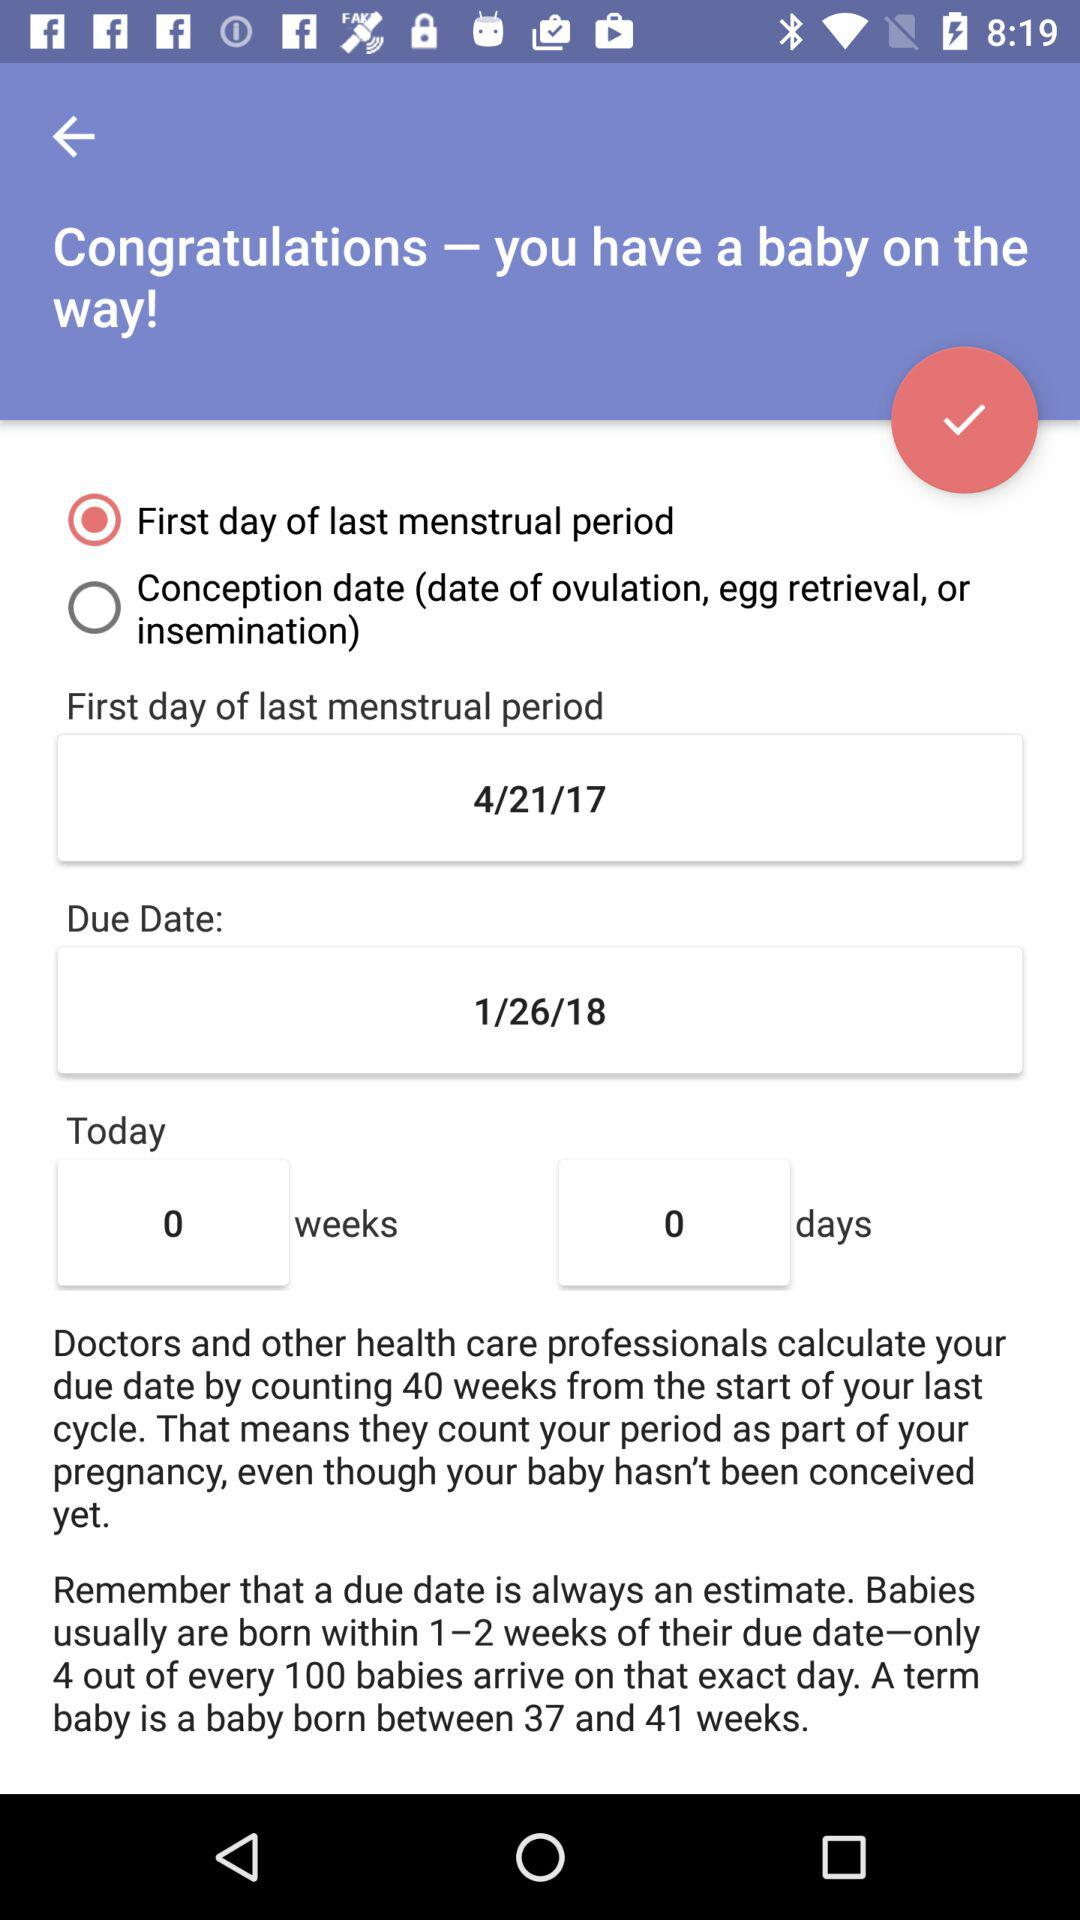What is the current status of the conception date? The status is off. 